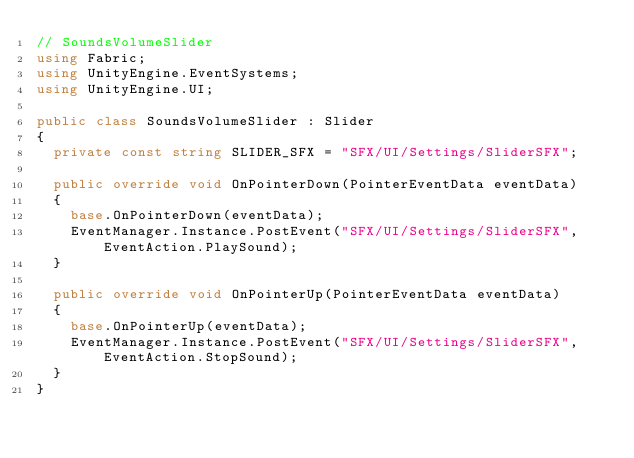<code> <loc_0><loc_0><loc_500><loc_500><_C#_>// SoundsVolumeSlider
using Fabric;
using UnityEngine.EventSystems;
using UnityEngine.UI;

public class SoundsVolumeSlider : Slider
{
	private const string SLIDER_SFX = "SFX/UI/Settings/SliderSFX";

	public override void OnPointerDown(PointerEventData eventData)
	{
		base.OnPointerDown(eventData);
		EventManager.Instance.PostEvent("SFX/UI/Settings/SliderSFX", EventAction.PlaySound);
	}

	public override void OnPointerUp(PointerEventData eventData)
	{
		base.OnPointerUp(eventData);
		EventManager.Instance.PostEvent("SFX/UI/Settings/SliderSFX", EventAction.StopSound);
	}
}
</code> 